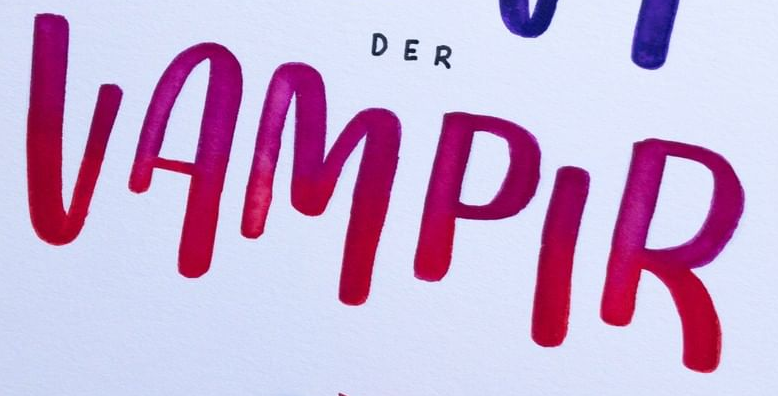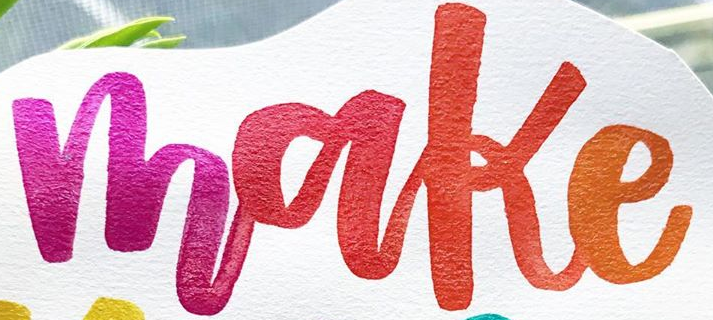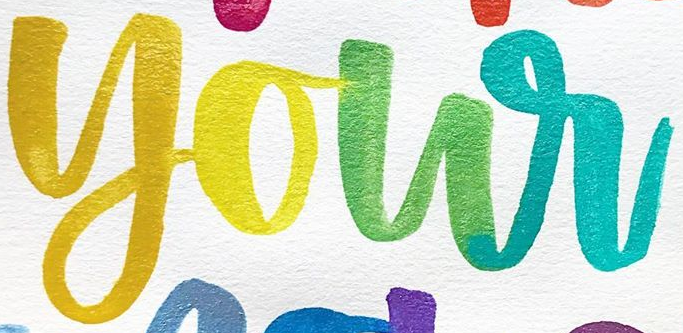Transcribe the words shown in these images in order, separated by a semicolon. VAMPIR; make; your 